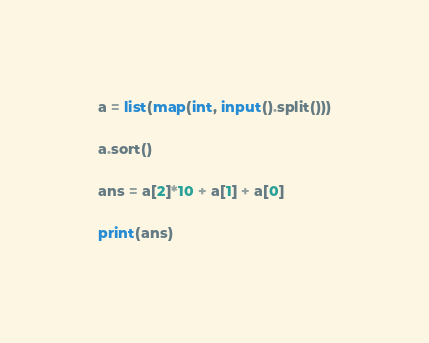<code> <loc_0><loc_0><loc_500><loc_500><_Python_>a = list(map(int, input().split()))

a.sort()

ans = a[2]*10 + a[1] + a[0]

print(ans)</code> 